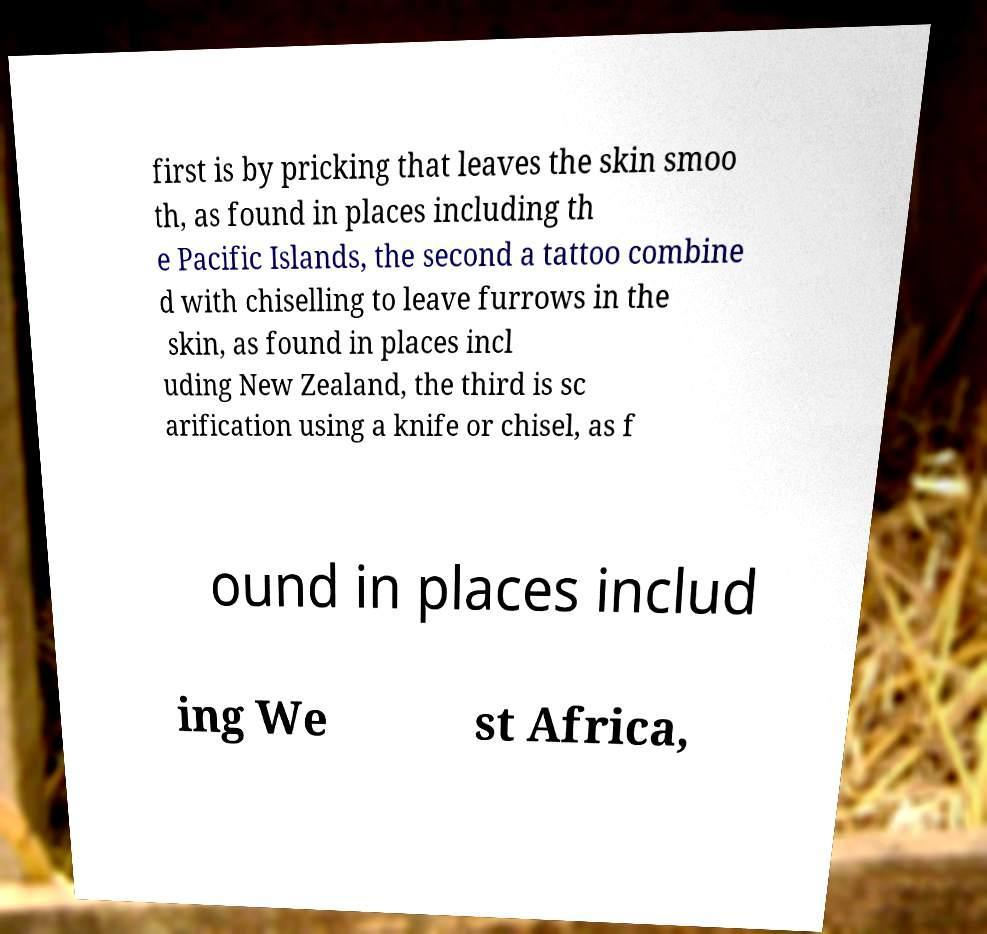There's text embedded in this image that I need extracted. Can you transcribe it verbatim? first is by pricking that leaves the skin smoo th, as found in places including th e Pacific Islands, the second a tattoo combine d with chiselling to leave furrows in the skin, as found in places incl uding New Zealand, the third is sc arification using a knife or chisel, as f ound in places includ ing We st Africa, 